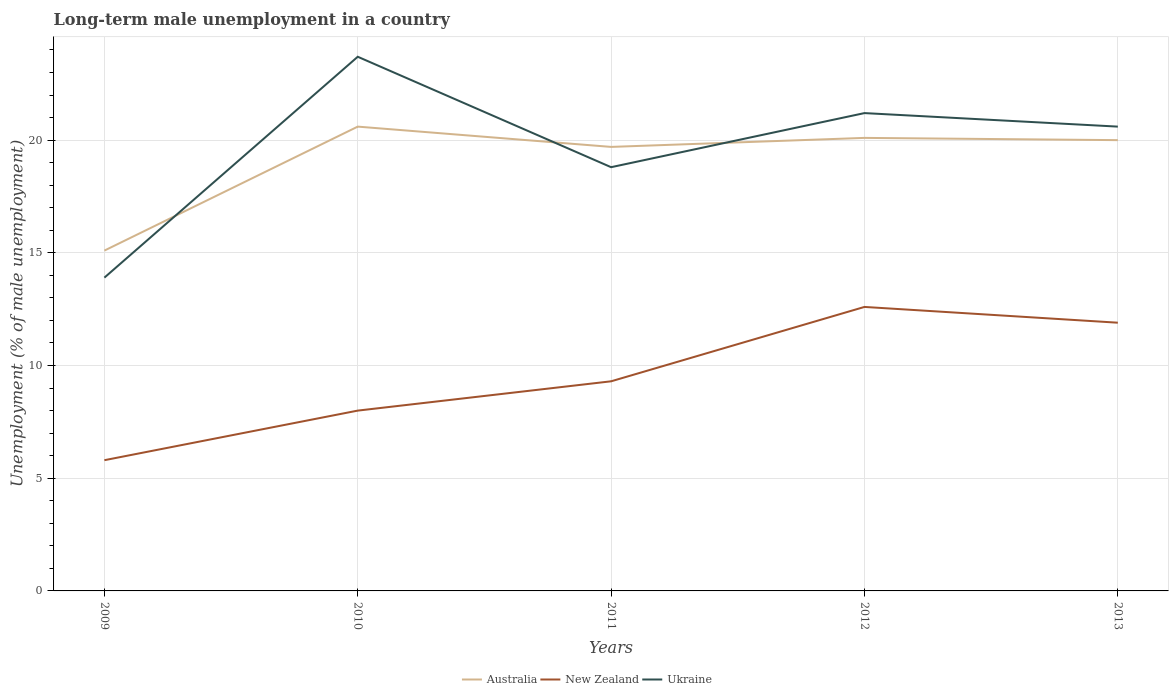Does the line corresponding to New Zealand intersect with the line corresponding to Australia?
Your response must be concise. No. Is the number of lines equal to the number of legend labels?
Your answer should be compact. Yes. Across all years, what is the maximum percentage of long-term unemployed male population in New Zealand?
Give a very brief answer. 5.8. In which year was the percentage of long-term unemployed male population in Ukraine maximum?
Your response must be concise. 2009. What is the total percentage of long-term unemployed male population in Australia in the graph?
Offer a terse response. 0.5. What is the difference between the highest and the second highest percentage of long-term unemployed male population in New Zealand?
Keep it short and to the point. 6.8. What is the difference between the highest and the lowest percentage of long-term unemployed male population in New Zealand?
Give a very brief answer. 2. Does the graph contain any zero values?
Offer a very short reply. No. Does the graph contain grids?
Provide a short and direct response. Yes. What is the title of the graph?
Provide a succinct answer. Long-term male unemployment in a country. What is the label or title of the X-axis?
Offer a very short reply. Years. What is the label or title of the Y-axis?
Give a very brief answer. Unemployment (% of male unemployment). What is the Unemployment (% of male unemployment) of Australia in 2009?
Provide a succinct answer. 15.1. What is the Unemployment (% of male unemployment) in New Zealand in 2009?
Provide a short and direct response. 5.8. What is the Unemployment (% of male unemployment) of Ukraine in 2009?
Give a very brief answer. 13.9. What is the Unemployment (% of male unemployment) of Australia in 2010?
Offer a terse response. 20.6. What is the Unemployment (% of male unemployment) in New Zealand in 2010?
Make the answer very short. 8. What is the Unemployment (% of male unemployment) of Ukraine in 2010?
Make the answer very short. 23.7. What is the Unemployment (% of male unemployment) of Australia in 2011?
Offer a very short reply. 19.7. What is the Unemployment (% of male unemployment) in New Zealand in 2011?
Your answer should be compact. 9.3. What is the Unemployment (% of male unemployment) in Ukraine in 2011?
Your answer should be very brief. 18.8. What is the Unemployment (% of male unemployment) of Australia in 2012?
Your answer should be very brief. 20.1. What is the Unemployment (% of male unemployment) in New Zealand in 2012?
Give a very brief answer. 12.6. What is the Unemployment (% of male unemployment) in Ukraine in 2012?
Your answer should be compact. 21.2. What is the Unemployment (% of male unemployment) of Australia in 2013?
Provide a succinct answer. 20. What is the Unemployment (% of male unemployment) of New Zealand in 2013?
Provide a succinct answer. 11.9. What is the Unemployment (% of male unemployment) of Ukraine in 2013?
Give a very brief answer. 20.6. Across all years, what is the maximum Unemployment (% of male unemployment) of Australia?
Provide a short and direct response. 20.6. Across all years, what is the maximum Unemployment (% of male unemployment) of New Zealand?
Give a very brief answer. 12.6. Across all years, what is the maximum Unemployment (% of male unemployment) of Ukraine?
Give a very brief answer. 23.7. Across all years, what is the minimum Unemployment (% of male unemployment) in Australia?
Offer a terse response. 15.1. Across all years, what is the minimum Unemployment (% of male unemployment) of New Zealand?
Your response must be concise. 5.8. Across all years, what is the minimum Unemployment (% of male unemployment) in Ukraine?
Give a very brief answer. 13.9. What is the total Unemployment (% of male unemployment) in Australia in the graph?
Ensure brevity in your answer.  95.5. What is the total Unemployment (% of male unemployment) in New Zealand in the graph?
Your answer should be very brief. 47.6. What is the total Unemployment (% of male unemployment) in Ukraine in the graph?
Provide a short and direct response. 98.2. What is the difference between the Unemployment (% of male unemployment) in Ukraine in 2009 and that in 2010?
Offer a terse response. -9.8. What is the difference between the Unemployment (% of male unemployment) in Australia in 2009 and that in 2011?
Offer a terse response. -4.6. What is the difference between the Unemployment (% of male unemployment) in Ukraine in 2009 and that in 2011?
Your response must be concise. -4.9. What is the difference between the Unemployment (% of male unemployment) of Australia in 2010 and that in 2011?
Make the answer very short. 0.9. What is the difference between the Unemployment (% of male unemployment) of Ukraine in 2010 and that in 2011?
Offer a terse response. 4.9. What is the difference between the Unemployment (% of male unemployment) of Australia in 2010 and that in 2012?
Provide a short and direct response. 0.5. What is the difference between the Unemployment (% of male unemployment) of Australia in 2010 and that in 2013?
Keep it short and to the point. 0.6. What is the difference between the Unemployment (% of male unemployment) in Ukraine in 2010 and that in 2013?
Offer a very short reply. 3.1. What is the difference between the Unemployment (% of male unemployment) of Australia in 2011 and that in 2012?
Your answer should be very brief. -0.4. What is the difference between the Unemployment (% of male unemployment) of New Zealand in 2011 and that in 2012?
Ensure brevity in your answer.  -3.3. What is the difference between the Unemployment (% of male unemployment) in Ukraine in 2011 and that in 2013?
Provide a short and direct response. -1.8. What is the difference between the Unemployment (% of male unemployment) of Australia in 2012 and that in 2013?
Ensure brevity in your answer.  0.1. What is the difference between the Unemployment (% of male unemployment) of New Zealand in 2009 and the Unemployment (% of male unemployment) of Ukraine in 2010?
Keep it short and to the point. -17.9. What is the difference between the Unemployment (% of male unemployment) in Australia in 2009 and the Unemployment (% of male unemployment) in New Zealand in 2011?
Make the answer very short. 5.8. What is the difference between the Unemployment (% of male unemployment) in Australia in 2009 and the Unemployment (% of male unemployment) in New Zealand in 2012?
Offer a terse response. 2.5. What is the difference between the Unemployment (% of male unemployment) of New Zealand in 2009 and the Unemployment (% of male unemployment) of Ukraine in 2012?
Offer a terse response. -15.4. What is the difference between the Unemployment (% of male unemployment) of New Zealand in 2009 and the Unemployment (% of male unemployment) of Ukraine in 2013?
Offer a terse response. -14.8. What is the difference between the Unemployment (% of male unemployment) in New Zealand in 2010 and the Unemployment (% of male unemployment) in Ukraine in 2011?
Offer a very short reply. -10.8. What is the difference between the Unemployment (% of male unemployment) in Australia in 2010 and the Unemployment (% of male unemployment) in New Zealand in 2013?
Offer a very short reply. 8.7. What is the difference between the Unemployment (% of male unemployment) of Australia in 2010 and the Unemployment (% of male unemployment) of Ukraine in 2013?
Your answer should be compact. 0. What is the difference between the Unemployment (% of male unemployment) in New Zealand in 2011 and the Unemployment (% of male unemployment) in Ukraine in 2012?
Offer a terse response. -11.9. What is the difference between the Unemployment (% of male unemployment) in Australia in 2011 and the Unemployment (% of male unemployment) in New Zealand in 2013?
Your answer should be compact. 7.8. What is the difference between the Unemployment (% of male unemployment) in Australia in 2011 and the Unemployment (% of male unemployment) in Ukraine in 2013?
Give a very brief answer. -0.9. What is the average Unemployment (% of male unemployment) of New Zealand per year?
Provide a succinct answer. 9.52. What is the average Unemployment (% of male unemployment) in Ukraine per year?
Give a very brief answer. 19.64. In the year 2009, what is the difference between the Unemployment (% of male unemployment) in Australia and Unemployment (% of male unemployment) in Ukraine?
Your response must be concise. 1.2. In the year 2009, what is the difference between the Unemployment (% of male unemployment) of New Zealand and Unemployment (% of male unemployment) of Ukraine?
Your response must be concise. -8.1. In the year 2010, what is the difference between the Unemployment (% of male unemployment) in Australia and Unemployment (% of male unemployment) in New Zealand?
Offer a very short reply. 12.6. In the year 2010, what is the difference between the Unemployment (% of male unemployment) of New Zealand and Unemployment (% of male unemployment) of Ukraine?
Your answer should be compact. -15.7. In the year 2011, what is the difference between the Unemployment (% of male unemployment) in Australia and Unemployment (% of male unemployment) in New Zealand?
Give a very brief answer. 10.4. In the year 2011, what is the difference between the Unemployment (% of male unemployment) in New Zealand and Unemployment (% of male unemployment) in Ukraine?
Make the answer very short. -9.5. In the year 2013, what is the difference between the Unemployment (% of male unemployment) in Australia and Unemployment (% of male unemployment) in Ukraine?
Ensure brevity in your answer.  -0.6. In the year 2013, what is the difference between the Unemployment (% of male unemployment) of New Zealand and Unemployment (% of male unemployment) of Ukraine?
Keep it short and to the point. -8.7. What is the ratio of the Unemployment (% of male unemployment) of Australia in 2009 to that in 2010?
Ensure brevity in your answer.  0.73. What is the ratio of the Unemployment (% of male unemployment) in New Zealand in 2009 to that in 2010?
Ensure brevity in your answer.  0.72. What is the ratio of the Unemployment (% of male unemployment) in Ukraine in 2009 to that in 2010?
Your answer should be compact. 0.59. What is the ratio of the Unemployment (% of male unemployment) of Australia in 2009 to that in 2011?
Make the answer very short. 0.77. What is the ratio of the Unemployment (% of male unemployment) of New Zealand in 2009 to that in 2011?
Make the answer very short. 0.62. What is the ratio of the Unemployment (% of male unemployment) of Ukraine in 2009 to that in 2011?
Make the answer very short. 0.74. What is the ratio of the Unemployment (% of male unemployment) of Australia in 2009 to that in 2012?
Offer a very short reply. 0.75. What is the ratio of the Unemployment (% of male unemployment) of New Zealand in 2009 to that in 2012?
Your response must be concise. 0.46. What is the ratio of the Unemployment (% of male unemployment) of Ukraine in 2009 to that in 2012?
Keep it short and to the point. 0.66. What is the ratio of the Unemployment (% of male unemployment) in Australia in 2009 to that in 2013?
Keep it short and to the point. 0.76. What is the ratio of the Unemployment (% of male unemployment) in New Zealand in 2009 to that in 2013?
Ensure brevity in your answer.  0.49. What is the ratio of the Unemployment (% of male unemployment) in Ukraine in 2009 to that in 2013?
Ensure brevity in your answer.  0.67. What is the ratio of the Unemployment (% of male unemployment) of Australia in 2010 to that in 2011?
Give a very brief answer. 1.05. What is the ratio of the Unemployment (% of male unemployment) of New Zealand in 2010 to that in 2011?
Keep it short and to the point. 0.86. What is the ratio of the Unemployment (% of male unemployment) in Ukraine in 2010 to that in 2011?
Provide a short and direct response. 1.26. What is the ratio of the Unemployment (% of male unemployment) in Australia in 2010 to that in 2012?
Make the answer very short. 1.02. What is the ratio of the Unemployment (% of male unemployment) of New Zealand in 2010 to that in 2012?
Your answer should be very brief. 0.63. What is the ratio of the Unemployment (% of male unemployment) in Ukraine in 2010 to that in 2012?
Provide a succinct answer. 1.12. What is the ratio of the Unemployment (% of male unemployment) in Australia in 2010 to that in 2013?
Give a very brief answer. 1.03. What is the ratio of the Unemployment (% of male unemployment) of New Zealand in 2010 to that in 2013?
Ensure brevity in your answer.  0.67. What is the ratio of the Unemployment (% of male unemployment) in Ukraine in 2010 to that in 2013?
Provide a short and direct response. 1.15. What is the ratio of the Unemployment (% of male unemployment) of Australia in 2011 to that in 2012?
Ensure brevity in your answer.  0.98. What is the ratio of the Unemployment (% of male unemployment) in New Zealand in 2011 to that in 2012?
Give a very brief answer. 0.74. What is the ratio of the Unemployment (% of male unemployment) of Ukraine in 2011 to that in 2012?
Give a very brief answer. 0.89. What is the ratio of the Unemployment (% of male unemployment) in Australia in 2011 to that in 2013?
Keep it short and to the point. 0.98. What is the ratio of the Unemployment (% of male unemployment) of New Zealand in 2011 to that in 2013?
Offer a very short reply. 0.78. What is the ratio of the Unemployment (% of male unemployment) of Ukraine in 2011 to that in 2013?
Offer a very short reply. 0.91. What is the ratio of the Unemployment (% of male unemployment) in Australia in 2012 to that in 2013?
Your answer should be compact. 1. What is the ratio of the Unemployment (% of male unemployment) of New Zealand in 2012 to that in 2013?
Your response must be concise. 1.06. What is the ratio of the Unemployment (% of male unemployment) in Ukraine in 2012 to that in 2013?
Provide a short and direct response. 1.03. What is the difference between the highest and the lowest Unemployment (% of male unemployment) of Australia?
Give a very brief answer. 5.5. 